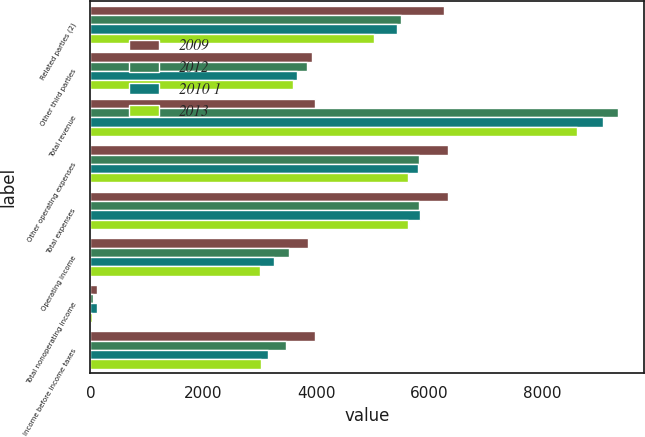Convert chart. <chart><loc_0><loc_0><loc_500><loc_500><stacked_bar_chart><ecel><fcel>Related parties (2)<fcel>Other third parties<fcel>Total revenue<fcel>Other operating expenses<fcel>Total expenses<fcel>Operating income<fcel>Total nonoperating income<fcel>Income before income taxes<nl><fcel>2009<fcel>6260<fcel>3920<fcel>3973<fcel>6323<fcel>6323<fcel>3857<fcel>116<fcel>3973<nl><fcel>2012<fcel>5501<fcel>3836<fcel>9337<fcel>5813<fcel>5813<fcel>3524<fcel>54<fcel>3470<nl><fcel>2010 1<fcel>5431<fcel>3650<fcel>9081<fcel>5800<fcel>5832<fcel>3249<fcel>114<fcel>3135<nl><fcel>2013<fcel>5025<fcel>3587<fcel>8612<fcel>5614<fcel>5614<fcel>2998<fcel>23<fcel>3021<nl></chart> 